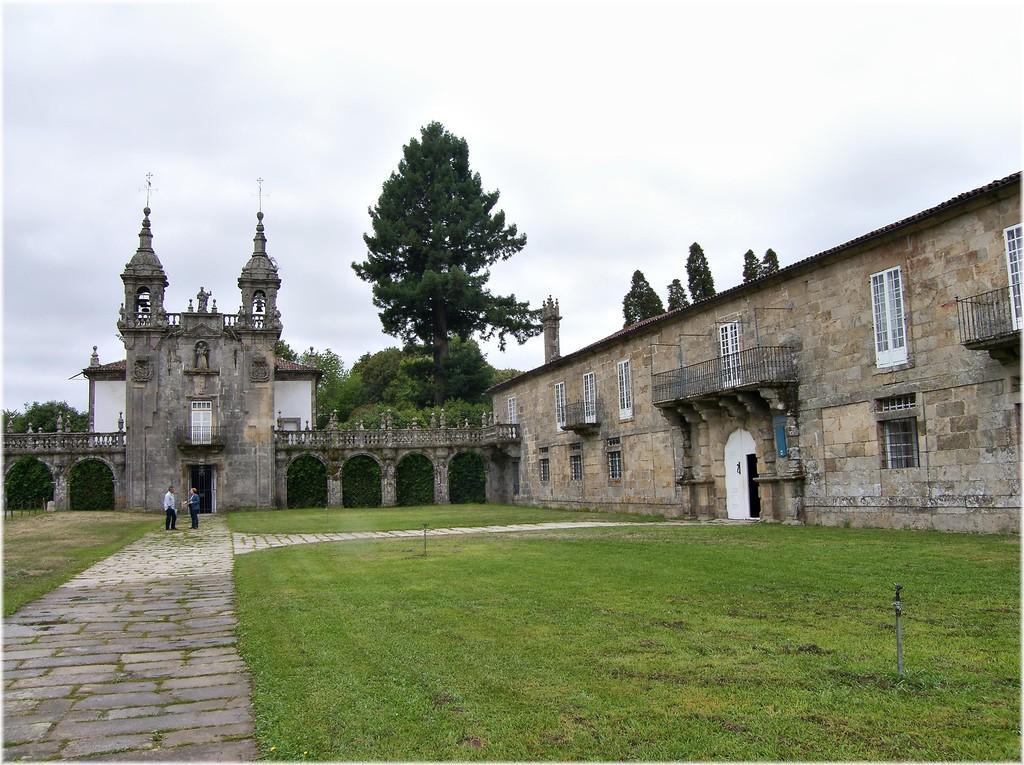Could you give a brief overview of what you see in this image? In this picture there is a castle with pillars, windows and a door. Towards the left, there is a lane. On the lane there are two persons. At the bottom, there is grass. In the background there are trees and sky. 